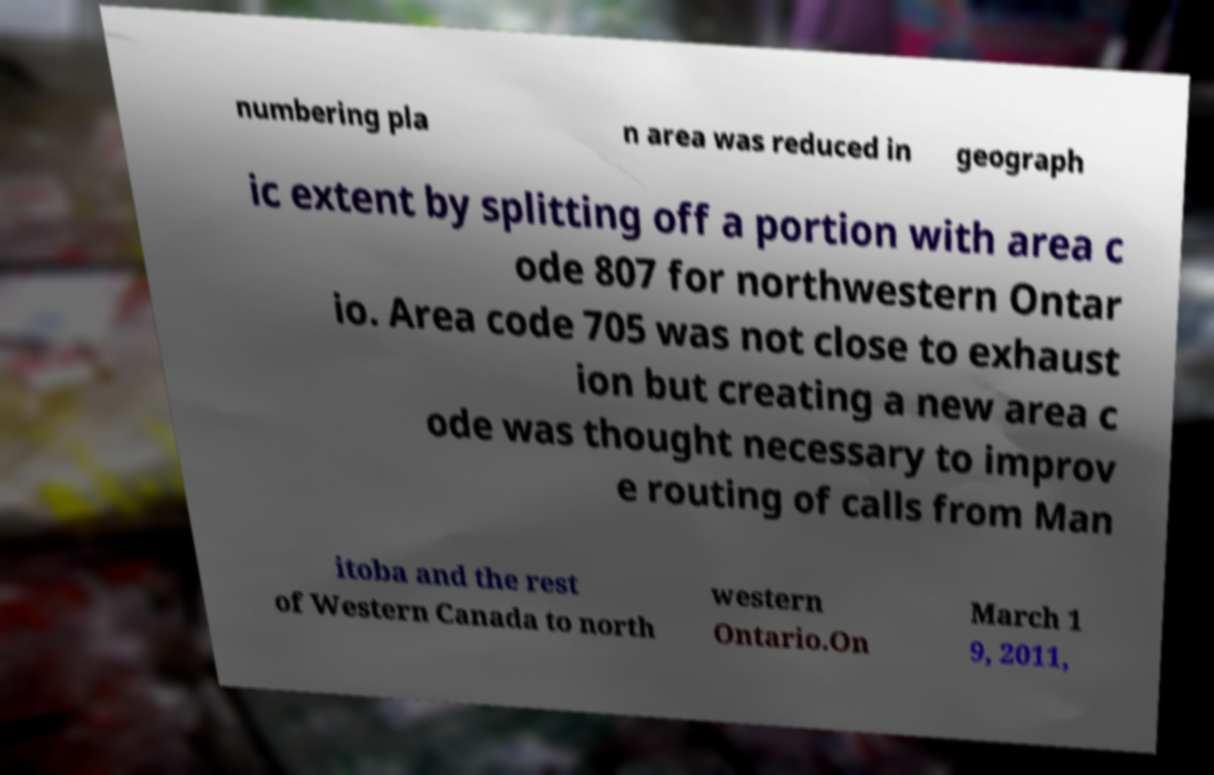For documentation purposes, I need the text within this image transcribed. Could you provide that? numbering pla n area was reduced in geograph ic extent by splitting off a portion with area c ode 807 for northwestern Ontar io. Area code 705 was not close to exhaust ion but creating a new area c ode was thought necessary to improv e routing of calls from Man itoba and the rest of Western Canada to north western Ontario.On March 1 9, 2011, 